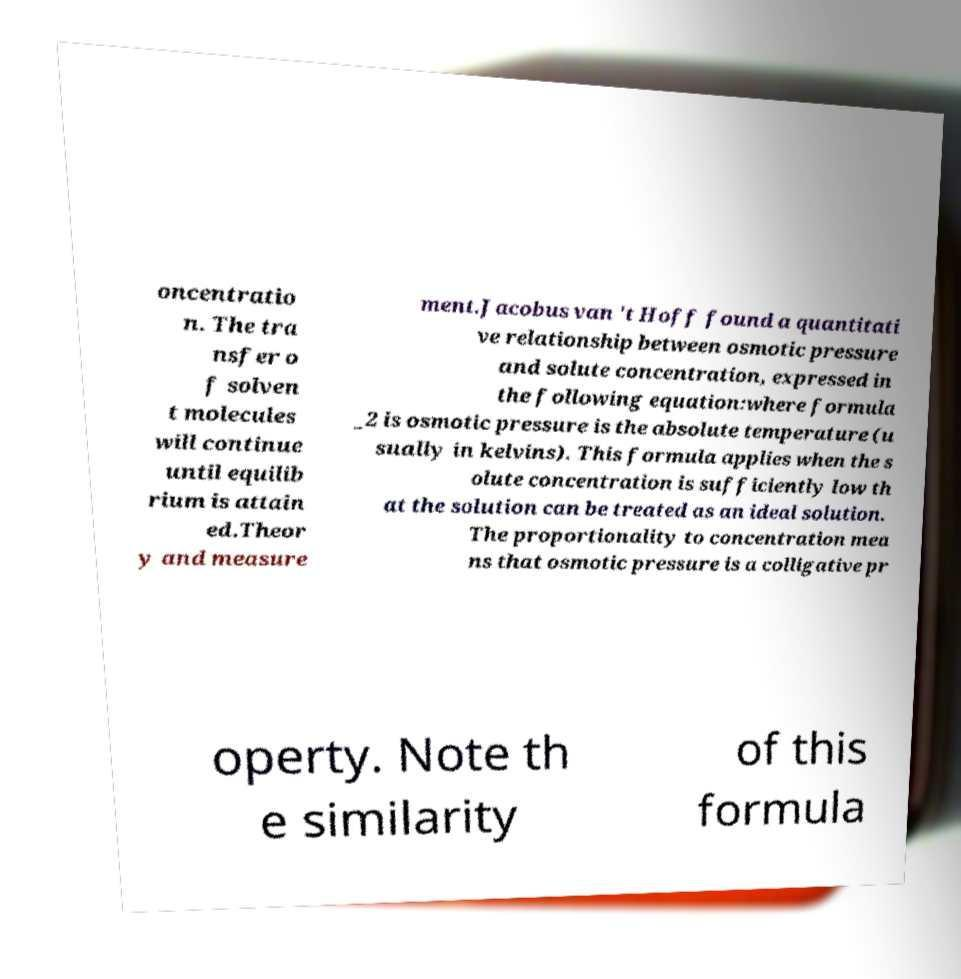Can you accurately transcribe the text from the provided image for me? oncentratio n. The tra nsfer o f solven t molecules will continue until equilib rium is attain ed.Theor y and measure ment.Jacobus van 't Hoff found a quantitati ve relationship between osmotic pressure and solute concentration, expressed in the following equation:where formula _2 is osmotic pressure is the absolute temperature (u sually in kelvins). This formula applies when the s olute concentration is sufficiently low th at the solution can be treated as an ideal solution. The proportionality to concentration mea ns that osmotic pressure is a colligative pr operty. Note th e similarity of this formula 